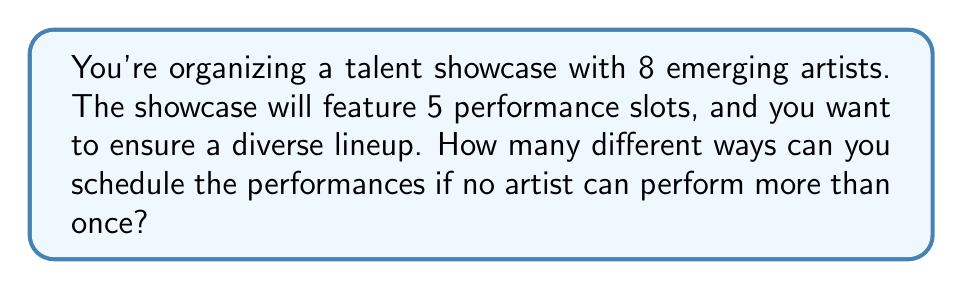Can you answer this question? Let's approach this step-by-step:

1) This is a permutation problem. We are selecting 5 artists out of 8 and arranging them in a specific order.

2) The formula for permutations without repetition is:

   $$P(n,r) = \frac{n!}{(n-r)!}$$

   Where $n$ is the total number of items to choose from, and $r$ is the number of items being chosen.

3) In this case, $n = 8$ (total number of artists) and $r = 5$ (number of performance slots).

4) Plugging these values into the formula:

   $$P(8,5) = \frac{8!}{(8-5)!} = \frac{8!}{3!}$$

5) Expand this:
   
   $$\frac{8 * 7 * 6 * 5 * 4 * 3!}{3!}$$

6) The $3!$ cancels out in the numerator and denominator:

   $$8 * 7 * 6 * 5 * 4 = 6720$$

Therefore, there are 6720 different ways to schedule the performances.
Answer: 6720 